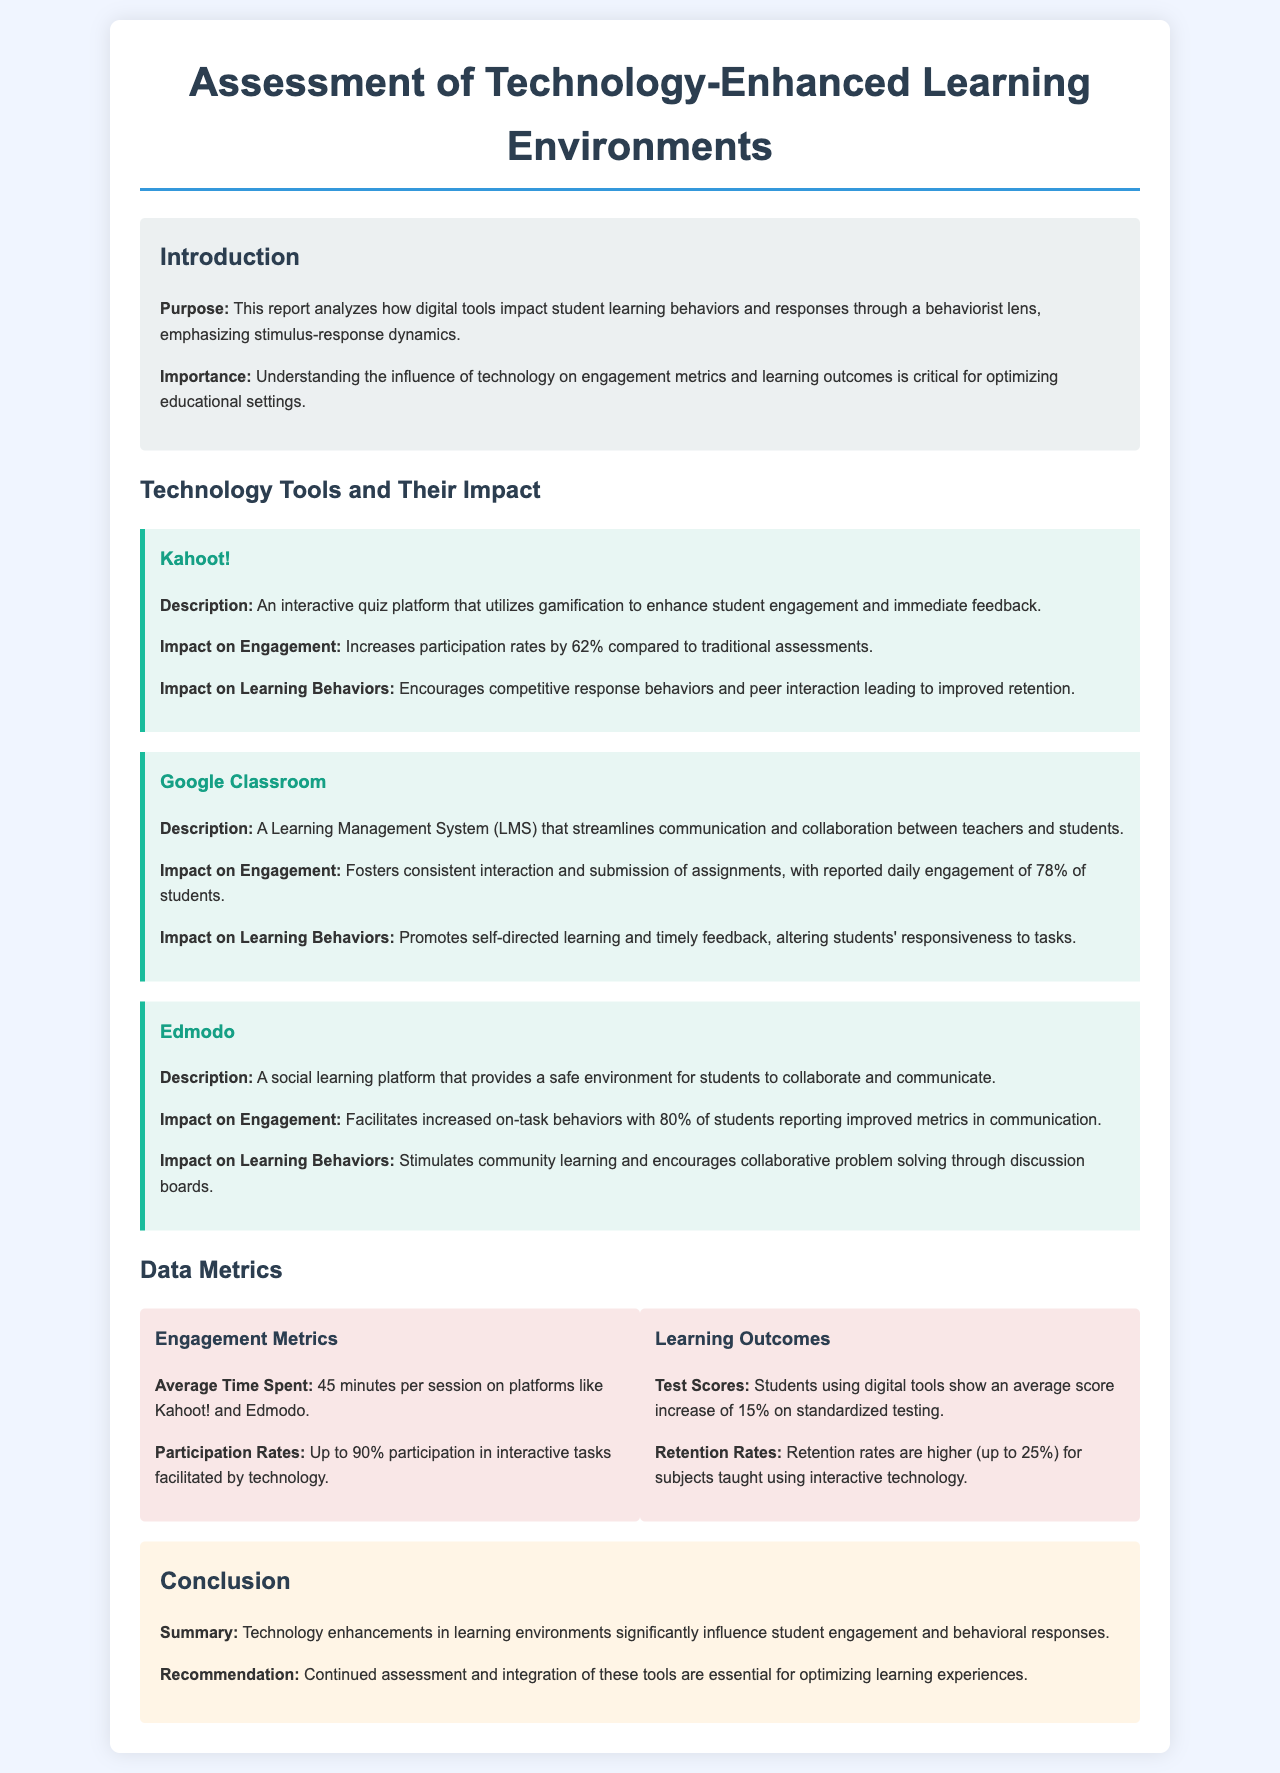What is the purpose of the report? The purpose of the report is to analyze how digital tools impact student learning behaviors and responses through a behaviorist lens, emphasizing stimulus-response dynamics.
Answer: Analyze how digital tools impact student learning behaviors and responses through a behaviorist lens What is the average score increase on standardized testing for students using digital tools? The document states that students using digital tools show an average score increase of 15% on standardized testing.
Answer: 15% What is the name of the interactive quiz platform mentioned? The report details Kahoot! as the interactive quiz platform that utilizes gamification for engagement.
Answer: Kahoot! What is the daily engagement percentage for students using Google Classroom? The document mentions that there is reported daily engagement of 78% of students in Google Classroom.
Answer: 78% What impact does Edmodo have on communication metrics? The report indicates that Edmodo facilitates increased on-task behaviors with 80% of students reporting improved metrics in communication.
Answer: 80% What is the average time spent per session on technology platforms? The report indicates that students spend an average time of 45 minutes per session on these platforms.
Answer: 45 minutes What overall conclusion is drawn about technology enhancements? The conclusion summarizes that technology enhancements in learning environments significantly influence student engagement and behavioral responses.
Answer: Significantly influence student engagement and behavioral responses What is recommended for optimizing learning experiences? The report concludes with the recommendation for continued assessment and integration of technology tools in education.
Answer: Continued assessment and integration of these tools 